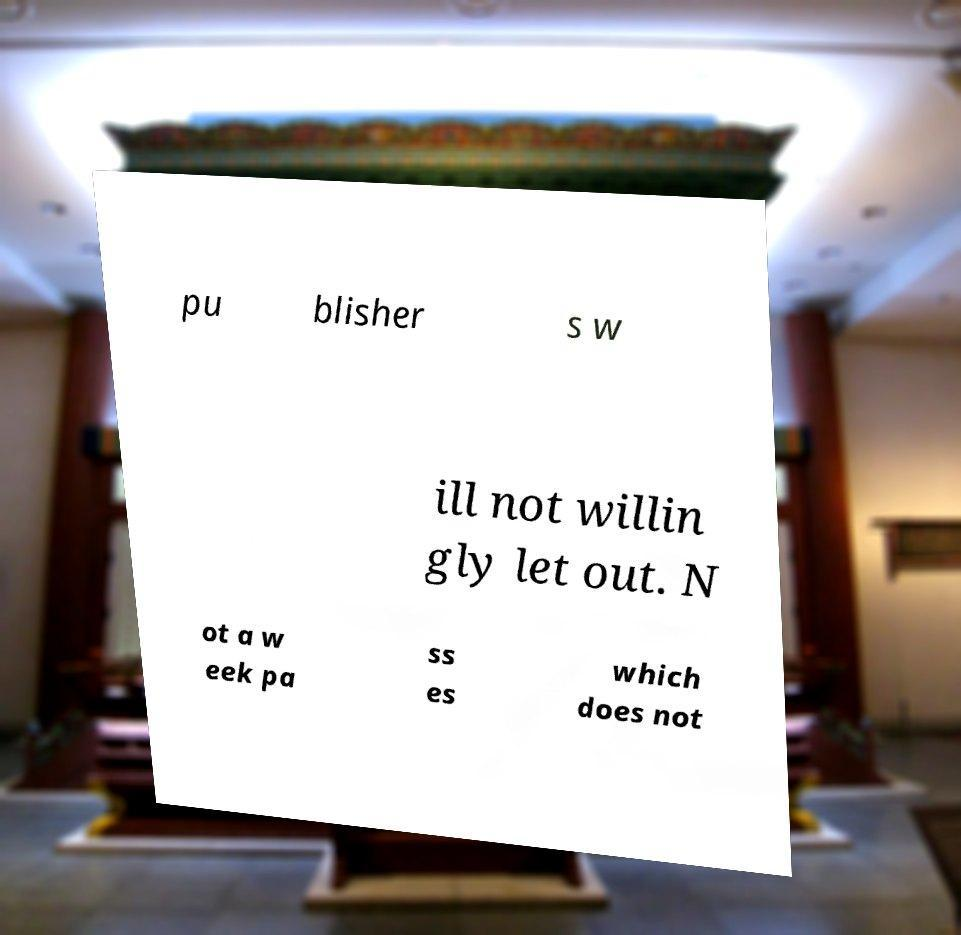Could you assist in decoding the text presented in this image and type it out clearly? pu blisher s w ill not willin gly let out. N ot a w eek pa ss es which does not 